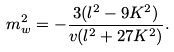<formula> <loc_0><loc_0><loc_500><loc_500>m ^ { 2 } _ { w } = - \frac { 3 ( l ^ { 2 } - 9 K ^ { 2 } ) } { v ( l ^ { 2 } + 2 7 K ^ { 2 } ) } .</formula> 